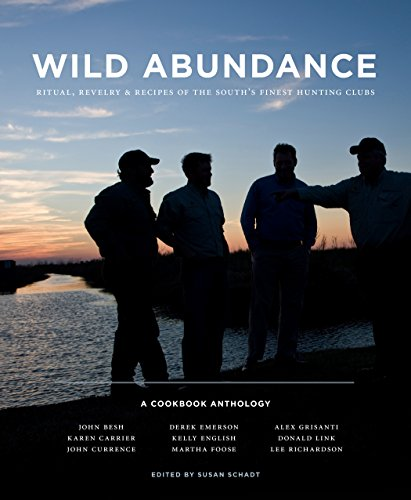Can you describe a typical gathering shown in this book? The book portrays gatherings that are rich in tradition, where the members of hunting clubs come together in the great outdoors to share a meal. These events are characterized by a strong sense of community and camaraderie, often featuring large, festive meals prepared with game and local ingredients, reflecting the cultural heritage of the region. 